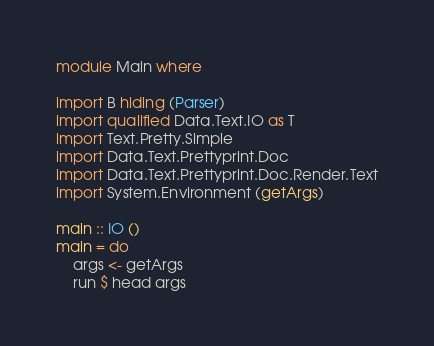<code> <loc_0><loc_0><loc_500><loc_500><_Haskell_>module Main where

import B hiding (Parser)
import qualified Data.Text.IO as T
import Text.Pretty.Simple
import Data.Text.Prettyprint.Doc
import Data.Text.Prettyprint.Doc.Render.Text
import System.Environment (getArgs)

main :: IO ()
main = do
    args <- getArgs
    run $ head args

</code> 